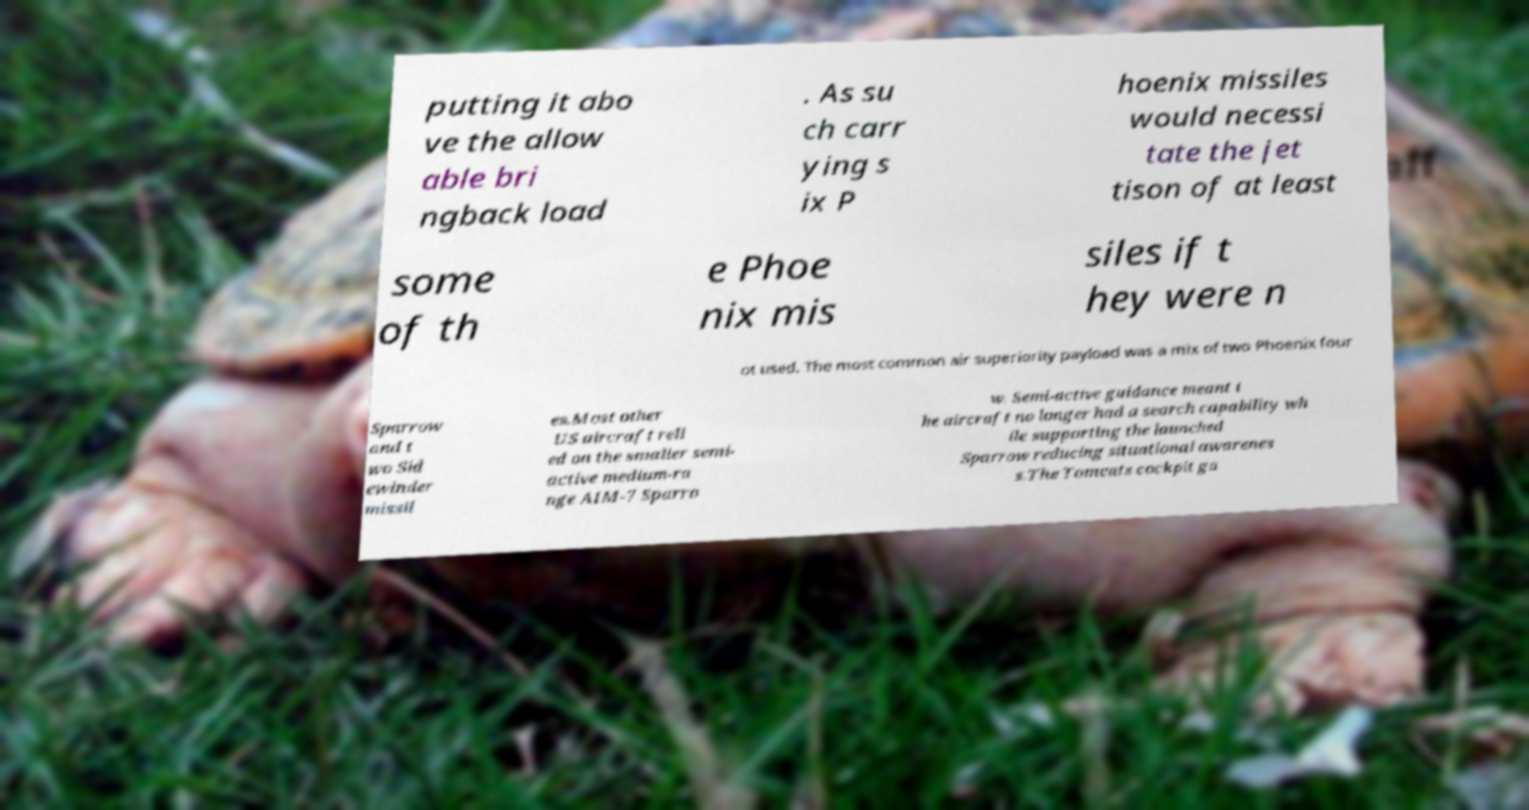What messages or text are displayed in this image? I need them in a readable, typed format. putting it abo ve the allow able bri ngback load . As su ch carr ying s ix P hoenix missiles would necessi tate the jet tison of at least some of th e Phoe nix mis siles if t hey were n ot used. The most common air superiority payload was a mix of two Phoenix four Sparrow and t wo Sid ewinder missil es.Most other US aircraft reli ed on the smaller semi- active medium-ra nge AIM-7 Sparro w. Semi-active guidance meant t he aircraft no longer had a search capability wh ile supporting the launched Sparrow reducing situational awarenes s.The Tomcats cockpit ga 